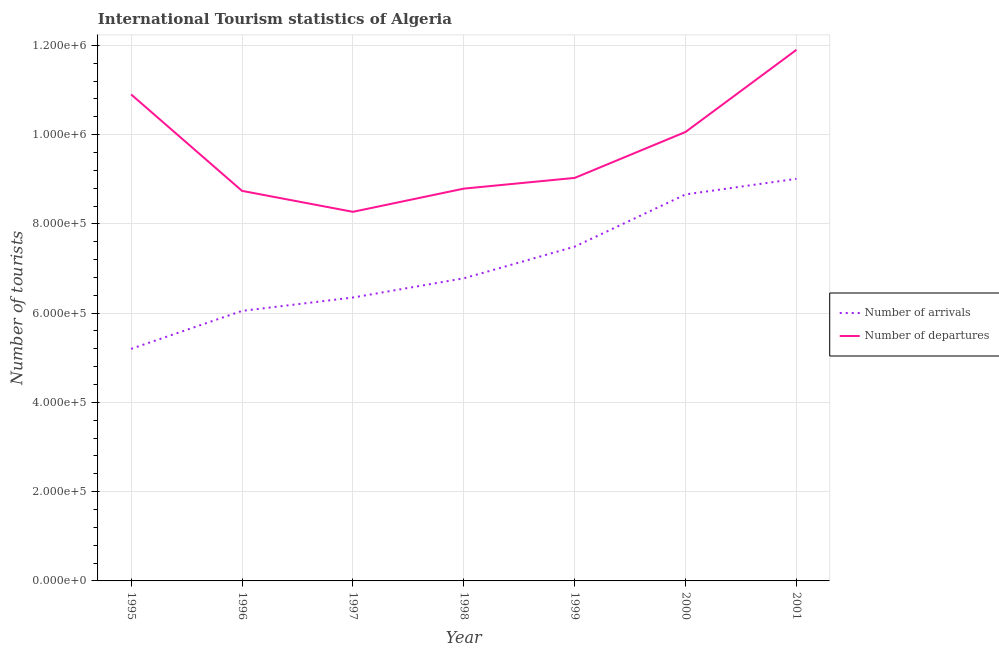How many different coloured lines are there?
Make the answer very short. 2. What is the number of tourist departures in 1997?
Offer a very short reply. 8.27e+05. Across all years, what is the maximum number of tourist arrivals?
Your answer should be compact. 9.01e+05. Across all years, what is the minimum number of tourist departures?
Your answer should be very brief. 8.27e+05. What is the total number of tourist departures in the graph?
Your response must be concise. 6.77e+06. What is the difference between the number of tourist departures in 1995 and that in 1996?
Provide a short and direct response. 2.16e+05. What is the difference between the number of tourist arrivals in 1999 and the number of tourist departures in 1995?
Keep it short and to the point. -3.41e+05. What is the average number of tourist departures per year?
Offer a terse response. 9.67e+05. In the year 1998, what is the difference between the number of tourist departures and number of tourist arrivals?
Your answer should be very brief. 2.01e+05. What is the ratio of the number of tourist arrivals in 1995 to that in 1999?
Your response must be concise. 0.69. Is the number of tourist departures in 1995 less than that in 2001?
Your answer should be compact. Yes. What is the difference between the highest and the lowest number of tourist departures?
Provide a succinct answer. 3.63e+05. In how many years, is the number of tourist arrivals greater than the average number of tourist arrivals taken over all years?
Offer a terse response. 3. Is the sum of the number of tourist arrivals in 1999 and 2001 greater than the maximum number of tourist departures across all years?
Offer a terse response. Yes. Is the number of tourist arrivals strictly greater than the number of tourist departures over the years?
Your answer should be compact. No. Is the number of tourist arrivals strictly less than the number of tourist departures over the years?
Give a very brief answer. Yes. Are the values on the major ticks of Y-axis written in scientific E-notation?
Provide a succinct answer. Yes. How many legend labels are there?
Your answer should be compact. 2. What is the title of the graph?
Ensure brevity in your answer.  International Tourism statistics of Algeria. Does "Stunting" appear as one of the legend labels in the graph?
Give a very brief answer. No. What is the label or title of the Y-axis?
Provide a short and direct response. Number of tourists. What is the Number of tourists in Number of arrivals in 1995?
Offer a very short reply. 5.20e+05. What is the Number of tourists of Number of departures in 1995?
Give a very brief answer. 1.09e+06. What is the Number of tourists in Number of arrivals in 1996?
Your answer should be very brief. 6.05e+05. What is the Number of tourists in Number of departures in 1996?
Your answer should be compact. 8.74e+05. What is the Number of tourists in Number of arrivals in 1997?
Offer a terse response. 6.35e+05. What is the Number of tourists of Number of departures in 1997?
Give a very brief answer. 8.27e+05. What is the Number of tourists in Number of arrivals in 1998?
Offer a very short reply. 6.78e+05. What is the Number of tourists in Number of departures in 1998?
Offer a terse response. 8.79e+05. What is the Number of tourists of Number of arrivals in 1999?
Your answer should be compact. 7.49e+05. What is the Number of tourists in Number of departures in 1999?
Provide a short and direct response. 9.03e+05. What is the Number of tourists of Number of arrivals in 2000?
Offer a very short reply. 8.66e+05. What is the Number of tourists of Number of departures in 2000?
Your answer should be compact. 1.01e+06. What is the Number of tourists in Number of arrivals in 2001?
Your answer should be very brief. 9.01e+05. What is the Number of tourists of Number of departures in 2001?
Provide a succinct answer. 1.19e+06. Across all years, what is the maximum Number of tourists in Number of arrivals?
Ensure brevity in your answer.  9.01e+05. Across all years, what is the maximum Number of tourists in Number of departures?
Keep it short and to the point. 1.19e+06. Across all years, what is the minimum Number of tourists in Number of arrivals?
Ensure brevity in your answer.  5.20e+05. Across all years, what is the minimum Number of tourists in Number of departures?
Make the answer very short. 8.27e+05. What is the total Number of tourists of Number of arrivals in the graph?
Keep it short and to the point. 4.95e+06. What is the total Number of tourists of Number of departures in the graph?
Your answer should be very brief. 6.77e+06. What is the difference between the Number of tourists of Number of arrivals in 1995 and that in 1996?
Keep it short and to the point. -8.50e+04. What is the difference between the Number of tourists in Number of departures in 1995 and that in 1996?
Your answer should be compact. 2.16e+05. What is the difference between the Number of tourists of Number of arrivals in 1995 and that in 1997?
Provide a succinct answer. -1.15e+05. What is the difference between the Number of tourists of Number of departures in 1995 and that in 1997?
Your answer should be very brief. 2.63e+05. What is the difference between the Number of tourists in Number of arrivals in 1995 and that in 1998?
Offer a terse response. -1.58e+05. What is the difference between the Number of tourists of Number of departures in 1995 and that in 1998?
Provide a short and direct response. 2.11e+05. What is the difference between the Number of tourists in Number of arrivals in 1995 and that in 1999?
Your answer should be very brief. -2.29e+05. What is the difference between the Number of tourists in Number of departures in 1995 and that in 1999?
Give a very brief answer. 1.87e+05. What is the difference between the Number of tourists of Number of arrivals in 1995 and that in 2000?
Offer a terse response. -3.46e+05. What is the difference between the Number of tourists of Number of departures in 1995 and that in 2000?
Keep it short and to the point. 8.40e+04. What is the difference between the Number of tourists of Number of arrivals in 1995 and that in 2001?
Offer a terse response. -3.81e+05. What is the difference between the Number of tourists of Number of arrivals in 1996 and that in 1997?
Your answer should be compact. -3.00e+04. What is the difference between the Number of tourists of Number of departures in 1996 and that in 1997?
Ensure brevity in your answer.  4.70e+04. What is the difference between the Number of tourists of Number of arrivals in 1996 and that in 1998?
Provide a succinct answer. -7.30e+04. What is the difference between the Number of tourists of Number of departures in 1996 and that in 1998?
Your response must be concise. -5000. What is the difference between the Number of tourists in Number of arrivals in 1996 and that in 1999?
Make the answer very short. -1.44e+05. What is the difference between the Number of tourists in Number of departures in 1996 and that in 1999?
Offer a very short reply. -2.90e+04. What is the difference between the Number of tourists in Number of arrivals in 1996 and that in 2000?
Your answer should be compact. -2.61e+05. What is the difference between the Number of tourists in Number of departures in 1996 and that in 2000?
Give a very brief answer. -1.32e+05. What is the difference between the Number of tourists in Number of arrivals in 1996 and that in 2001?
Your answer should be compact. -2.96e+05. What is the difference between the Number of tourists of Number of departures in 1996 and that in 2001?
Provide a succinct answer. -3.16e+05. What is the difference between the Number of tourists of Number of arrivals in 1997 and that in 1998?
Ensure brevity in your answer.  -4.30e+04. What is the difference between the Number of tourists in Number of departures in 1997 and that in 1998?
Provide a succinct answer. -5.20e+04. What is the difference between the Number of tourists in Number of arrivals in 1997 and that in 1999?
Make the answer very short. -1.14e+05. What is the difference between the Number of tourists in Number of departures in 1997 and that in 1999?
Provide a short and direct response. -7.60e+04. What is the difference between the Number of tourists in Number of arrivals in 1997 and that in 2000?
Provide a succinct answer. -2.31e+05. What is the difference between the Number of tourists in Number of departures in 1997 and that in 2000?
Keep it short and to the point. -1.79e+05. What is the difference between the Number of tourists in Number of arrivals in 1997 and that in 2001?
Your answer should be very brief. -2.66e+05. What is the difference between the Number of tourists in Number of departures in 1997 and that in 2001?
Provide a short and direct response. -3.63e+05. What is the difference between the Number of tourists of Number of arrivals in 1998 and that in 1999?
Your answer should be compact. -7.10e+04. What is the difference between the Number of tourists in Number of departures in 1998 and that in 1999?
Ensure brevity in your answer.  -2.40e+04. What is the difference between the Number of tourists of Number of arrivals in 1998 and that in 2000?
Your answer should be compact. -1.88e+05. What is the difference between the Number of tourists of Number of departures in 1998 and that in 2000?
Provide a succinct answer. -1.27e+05. What is the difference between the Number of tourists of Number of arrivals in 1998 and that in 2001?
Your answer should be compact. -2.23e+05. What is the difference between the Number of tourists in Number of departures in 1998 and that in 2001?
Your response must be concise. -3.11e+05. What is the difference between the Number of tourists in Number of arrivals in 1999 and that in 2000?
Your answer should be compact. -1.17e+05. What is the difference between the Number of tourists of Number of departures in 1999 and that in 2000?
Give a very brief answer. -1.03e+05. What is the difference between the Number of tourists of Number of arrivals in 1999 and that in 2001?
Offer a terse response. -1.52e+05. What is the difference between the Number of tourists of Number of departures in 1999 and that in 2001?
Offer a very short reply. -2.87e+05. What is the difference between the Number of tourists in Number of arrivals in 2000 and that in 2001?
Offer a terse response. -3.50e+04. What is the difference between the Number of tourists in Number of departures in 2000 and that in 2001?
Provide a short and direct response. -1.84e+05. What is the difference between the Number of tourists in Number of arrivals in 1995 and the Number of tourists in Number of departures in 1996?
Your answer should be compact. -3.54e+05. What is the difference between the Number of tourists in Number of arrivals in 1995 and the Number of tourists in Number of departures in 1997?
Your answer should be very brief. -3.07e+05. What is the difference between the Number of tourists in Number of arrivals in 1995 and the Number of tourists in Number of departures in 1998?
Provide a short and direct response. -3.59e+05. What is the difference between the Number of tourists of Number of arrivals in 1995 and the Number of tourists of Number of departures in 1999?
Ensure brevity in your answer.  -3.83e+05. What is the difference between the Number of tourists of Number of arrivals in 1995 and the Number of tourists of Number of departures in 2000?
Offer a terse response. -4.86e+05. What is the difference between the Number of tourists of Number of arrivals in 1995 and the Number of tourists of Number of departures in 2001?
Your answer should be very brief. -6.70e+05. What is the difference between the Number of tourists of Number of arrivals in 1996 and the Number of tourists of Number of departures in 1997?
Offer a terse response. -2.22e+05. What is the difference between the Number of tourists of Number of arrivals in 1996 and the Number of tourists of Number of departures in 1998?
Ensure brevity in your answer.  -2.74e+05. What is the difference between the Number of tourists of Number of arrivals in 1996 and the Number of tourists of Number of departures in 1999?
Your response must be concise. -2.98e+05. What is the difference between the Number of tourists of Number of arrivals in 1996 and the Number of tourists of Number of departures in 2000?
Offer a terse response. -4.01e+05. What is the difference between the Number of tourists of Number of arrivals in 1996 and the Number of tourists of Number of departures in 2001?
Your answer should be compact. -5.85e+05. What is the difference between the Number of tourists of Number of arrivals in 1997 and the Number of tourists of Number of departures in 1998?
Your response must be concise. -2.44e+05. What is the difference between the Number of tourists of Number of arrivals in 1997 and the Number of tourists of Number of departures in 1999?
Ensure brevity in your answer.  -2.68e+05. What is the difference between the Number of tourists of Number of arrivals in 1997 and the Number of tourists of Number of departures in 2000?
Your answer should be very brief. -3.71e+05. What is the difference between the Number of tourists of Number of arrivals in 1997 and the Number of tourists of Number of departures in 2001?
Your answer should be very brief. -5.55e+05. What is the difference between the Number of tourists in Number of arrivals in 1998 and the Number of tourists in Number of departures in 1999?
Your response must be concise. -2.25e+05. What is the difference between the Number of tourists in Number of arrivals in 1998 and the Number of tourists in Number of departures in 2000?
Provide a succinct answer. -3.28e+05. What is the difference between the Number of tourists of Number of arrivals in 1998 and the Number of tourists of Number of departures in 2001?
Make the answer very short. -5.12e+05. What is the difference between the Number of tourists of Number of arrivals in 1999 and the Number of tourists of Number of departures in 2000?
Make the answer very short. -2.57e+05. What is the difference between the Number of tourists in Number of arrivals in 1999 and the Number of tourists in Number of departures in 2001?
Ensure brevity in your answer.  -4.41e+05. What is the difference between the Number of tourists of Number of arrivals in 2000 and the Number of tourists of Number of departures in 2001?
Give a very brief answer. -3.24e+05. What is the average Number of tourists of Number of arrivals per year?
Your answer should be compact. 7.08e+05. What is the average Number of tourists of Number of departures per year?
Ensure brevity in your answer.  9.67e+05. In the year 1995, what is the difference between the Number of tourists in Number of arrivals and Number of tourists in Number of departures?
Ensure brevity in your answer.  -5.70e+05. In the year 1996, what is the difference between the Number of tourists of Number of arrivals and Number of tourists of Number of departures?
Provide a short and direct response. -2.69e+05. In the year 1997, what is the difference between the Number of tourists of Number of arrivals and Number of tourists of Number of departures?
Offer a very short reply. -1.92e+05. In the year 1998, what is the difference between the Number of tourists in Number of arrivals and Number of tourists in Number of departures?
Provide a short and direct response. -2.01e+05. In the year 1999, what is the difference between the Number of tourists of Number of arrivals and Number of tourists of Number of departures?
Your response must be concise. -1.54e+05. In the year 2001, what is the difference between the Number of tourists in Number of arrivals and Number of tourists in Number of departures?
Keep it short and to the point. -2.89e+05. What is the ratio of the Number of tourists in Number of arrivals in 1995 to that in 1996?
Your answer should be compact. 0.86. What is the ratio of the Number of tourists in Number of departures in 1995 to that in 1996?
Offer a terse response. 1.25. What is the ratio of the Number of tourists of Number of arrivals in 1995 to that in 1997?
Keep it short and to the point. 0.82. What is the ratio of the Number of tourists of Number of departures in 1995 to that in 1997?
Give a very brief answer. 1.32. What is the ratio of the Number of tourists in Number of arrivals in 1995 to that in 1998?
Your answer should be very brief. 0.77. What is the ratio of the Number of tourists in Number of departures in 1995 to that in 1998?
Your answer should be very brief. 1.24. What is the ratio of the Number of tourists of Number of arrivals in 1995 to that in 1999?
Provide a short and direct response. 0.69. What is the ratio of the Number of tourists in Number of departures in 1995 to that in 1999?
Your answer should be very brief. 1.21. What is the ratio of the Number of tourists in Number of arrivals in 1995 to that in 2000?
Make the answer very short. 0.6. What is the ratio of the Number of tourists in Number of departures in 1995 to that in 2000?
Make the answer very short. 1.08. What is the ratio of the Number of tourists of Number of arrivals in 1995 to that in 2001?
Provide a short and direct response. 0.58. What is the ratio of the Number of tourists of Number of departures in 1995 to that in 2001?
Make the answer very short. 0.92. What is the ratio of the Number of tourists of Number of arrivals in 1996 to that in 1997?
Your answer should be very brief. 0.95. What is the ratio of the Number of tourists in Number of departures in 1996 to that in 1997?
Your answer should be compact. 1.06. What is the ratio of the Number of tourists in Number of arrivals in 1996 to that in 1998?
Give a very brief answer. 0.89. What is the ratio of the Number of tourists in Number of arrivals in 1996 to that in 1999?
Provide a short and direct response. 0.81. What is the ratio of the Number of tourists of Number of departures in 1996 to that in 1999?
Provide a short and direct response. 0.97. What is the ratio of the Number of tourists of Number of arrivals in 1996 to that in 2000?
Provide a succinct answer. 0.7. What is the ratio of the Number of tourists of Number of departures in 1996 to that in 2000?
Provide a succinct answer. 0.87. What is the ratio of the Number of tourists in Number of arrivals in 1996 to that in 2001?
Your response must be concise. 0.67. What is the ratio of the Number of tourists in Number of departures in 1996 to that in 2001?
Your answer should be very brief. 0.73. What is the ratio of the Number of tourists of Number of arrivals in 1997 to that in 1998?
Give a very brief answer. 0.94. What is the ratio of the Number of tourists of Number of departures in 1997 to that in 1998?
Your response must be concise. 0.94. What is the ratio of the Number of tourists of Number of arrivals in 1997 to that in 1999?
Keep it short and to the point. 0.85. What is the ratio of the Number of tourists of Number of departures in 1997 to that in 1999?
Your answer should be very brief. 0.92. What is the ratio of the Number of tourists of Number of arrivals in 1997 to that in 2000?
Offer a terse response. 0.73. What is the ratio of the Number of tourists of Number of departures in 1997 to that in 2000?
Your answer should be very brief. 0.82. What is the ratio of the Number of tourists in Number of arrivals in 1997 to that in 2001?
Keep it short and to the point. 0.7. What is the ratio of the Number of tourists of Number of departures in 1997 to that in 2001?
Ensure brevity in your answer.  0.69. What is the ratio of the Number of tourists of Number of arrivals in 1998 to that in 1999?
Ensure brevity in your answer.  0.91. What is the ratio of the Number of tourists of Number of departures in 1998 to that in 1999?
Keep it short and to the point. 0.97. What is the ratio of the Number of tourists in Number of arrivals in 1998 to that in 2000?
Your answer should be compact. 0.78. What is the ratio of the Number of tourists of Number of departures in 1998 to that in 2000?
Your answer should be compact. 0.87. What is the ratio of the Number of tourists in Number of arrivals in 1998 to that in 2001?
Keep it short and to the point. 0.75. What is the ratio of the Number of tourists of Number of departures in 1998 to that in 2001?
Make the answer very short. 0.74. What is the ratio of the Number of tourists in Number of arrivals in 1999 to that in 2000?
Your answer should be very brief. 0.86. What is the ratio of the Number of tourists of Number of departures in 1999 to that in 2000?
Your response must be concise. 0.9. What is the ratio of the Number of tourists of Number of arrivals in 1999 to that in 2001?
Your response must be concise. 0.83. What is the ratio of the Number of tourists of Number of departures in 1999 to that in 2001?
Keep it short and to the point. 0.76. What is the ratio of the Number of tourists of Number of arrivals in 2000 to that in 2001?
Offer a terse response. 0.96. What is the ratio of the Number of tourists of Number of departures in 2000 to that in 2001?
Keep it short and to the point. 0.85. What is the difference between the highest and the second highest Number of tourists of Number of arrivals?
Provide a succinct answer. 3.50e+04. What is the difference between the highest and the second highest Number of tourists of Number of departures?
Offer a very short reply. 1.00e+05. What is the difference between the highest and the lowest Number of tourists in Number of arrivals?
Provide a short and direct response. 3.81e+05. What is the difference between the highest and the lowest Number of tourists of Number of departures?
Offer a terse response. 3.63e+05. 